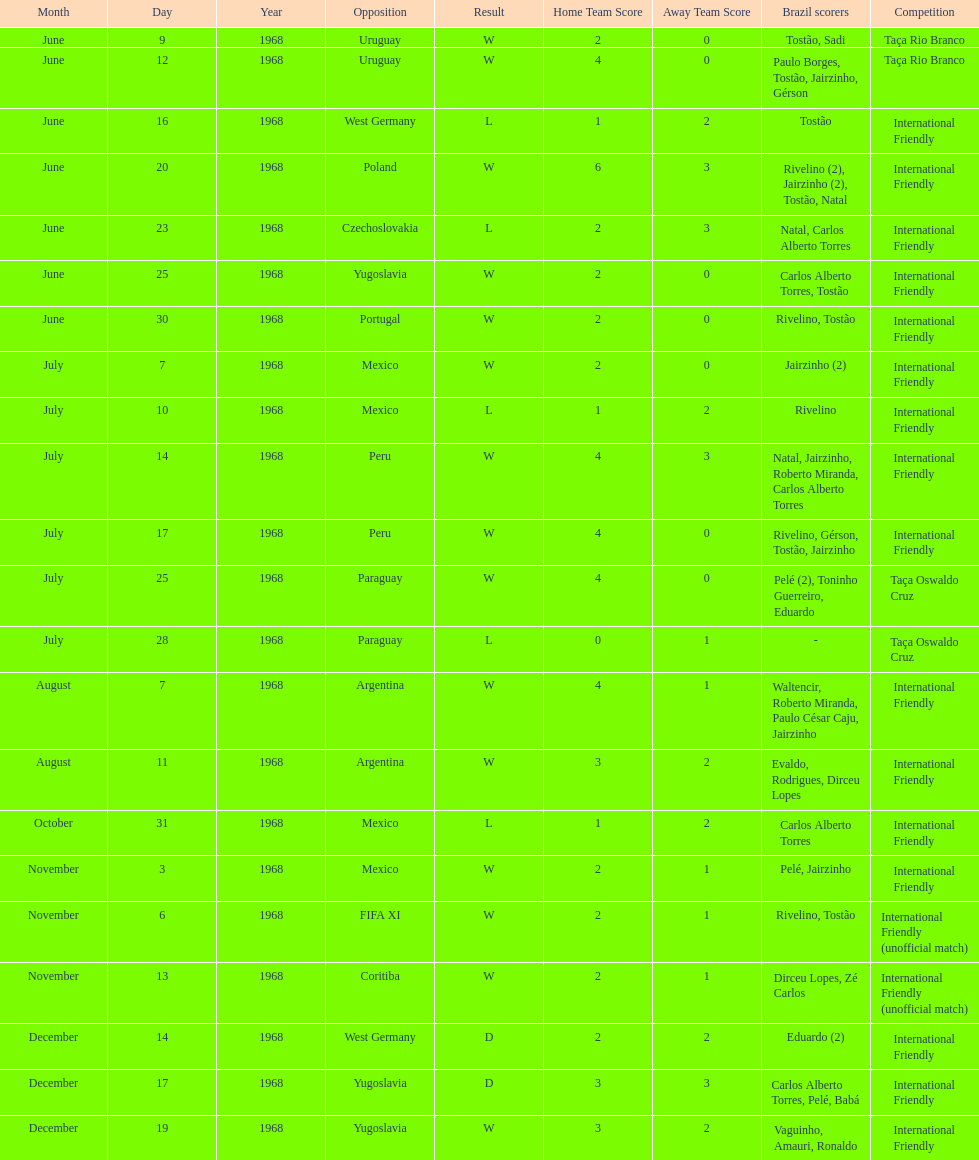How many times did brazil score during the game on november 6th? 2. 